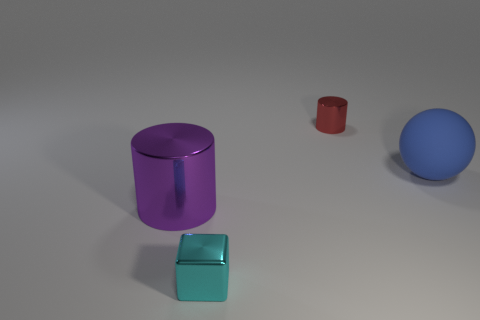What number of large blue things are the same shape as the purple thing?
Give a very brief answer. 0. Are there any other things that have the same shape as the cyan shiny object?
Ensure brevity in your answer.  No. There is a object in front of the metallic cylinder that is in front of the cylinder behind the large blue matte sphere; what is its color?
Your answer should be compact. Cyan. How many small things are red cylinders or cyan shiny objects?
Provide a succinct answer. 2. Is the number of tiny metallic cylinders that are in front of the big metal cylinder the same as the number of small gray metallic blocks?
Provide a short and direct response. Yes. There is a blue rubber thing; are there any metallic cubes behind it?
Offer a very short reply. No. What number of shiny things are either large balls or purple balls?
Ensure brevity in your answer.  0. What number of cyan things are behind the small red thing?
Offer a terse response. 0. Is there a purple metallic cylinder that has the same size as the matte sphere?
Your answer should be very brief. Yes. Are there any rubber balls of the same color as the block?
Your answer should be very brief. No. 